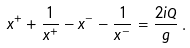Convert formula to latex. <formula><loc_0><loc_0><loc_500><loc_500>x ^ { + } + \frac { 1 } { x ^ { + } } - x ^ { - } - \frac { 1 } { x ^ { - } } = \frac { 2 i Q } { g } \, .</formula> 